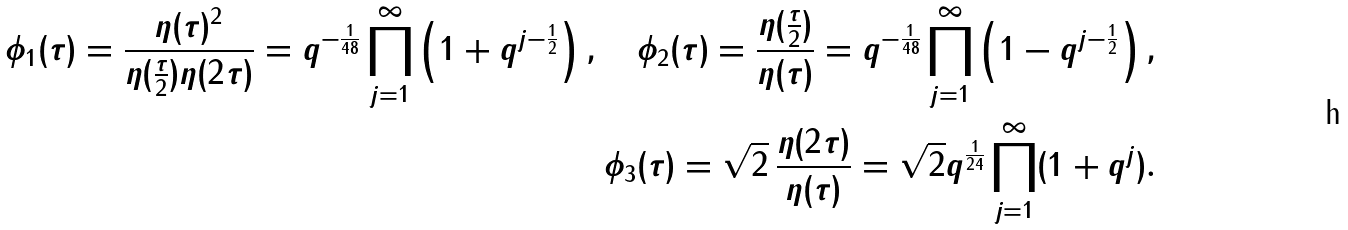Convert formula to latex. <formula><loc_0><loc_0><loc_500><loc_500>\phi _ { 1 } ( \tau ) = \frac { \eta ( \tau ) ^ { 2 } } { \eta ( \frac { \tau } { 2 } ) \eta ( 2 \tau ) } = q ^ { - \frac { 1 } { 4 8 } } \prod _ { j = 1 } ^ { \infty } \left ( 1 + q ^ { j - \frac { 1 } { 2 } } \right ) , \quad \phi _ { 2 } ( \tau ) = \frac { \eta ( \frac { \tau } { 2 } ) } { \eta ( \tau ) } = q ^ { - \frac { 1 } { 4 8 } } \prod _ { j = 1 } ^ { \infty } \left ( 1 - q ^ { j - \frac { 1 } { 2 } } \right ) , \\ \phi _ { 3 } ( \tau ) = \sqrt { 2 } \, \frac { \eta ( 2 \tau ) } { \eta ( \tau ) } = \sqrt { 2 } q ^ { \frac { 1 } { 2 4 } } \prod _ { j = 1 } ^ { \infty } ( 1 + q ^ { j } ) .</formula> 